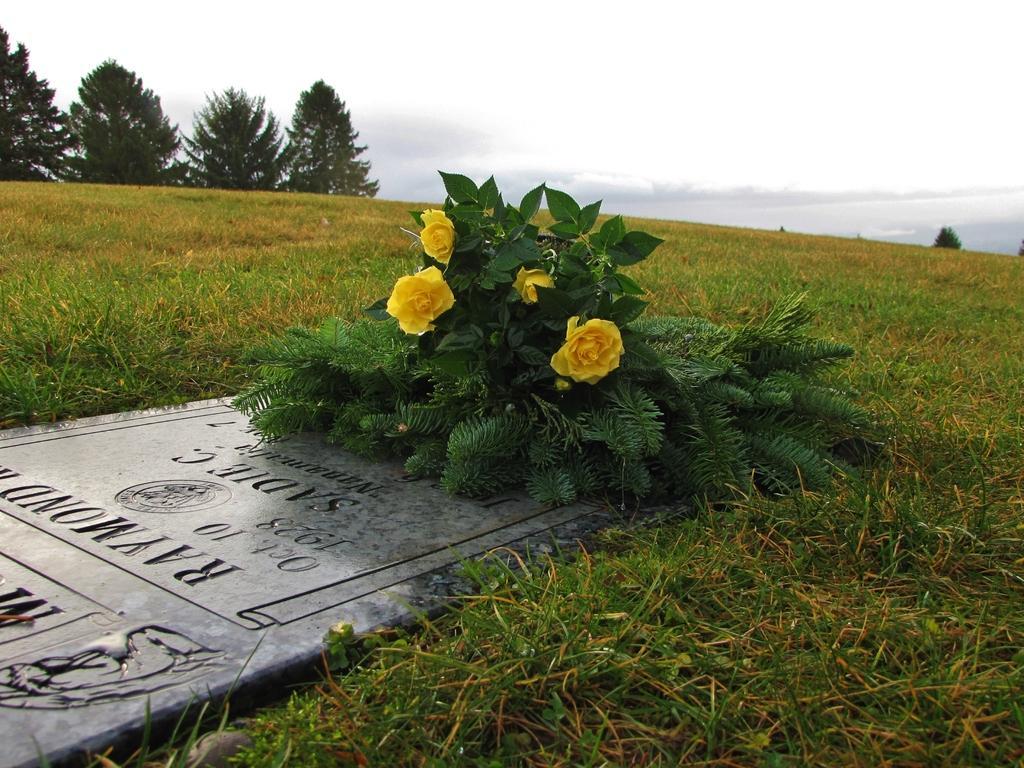Can you describe this image briefly? In this image we can see a stone. On the stone we can see the text and a bouquet. Beside the stone we can see the grass. At the top we can see the trees and the sky. 